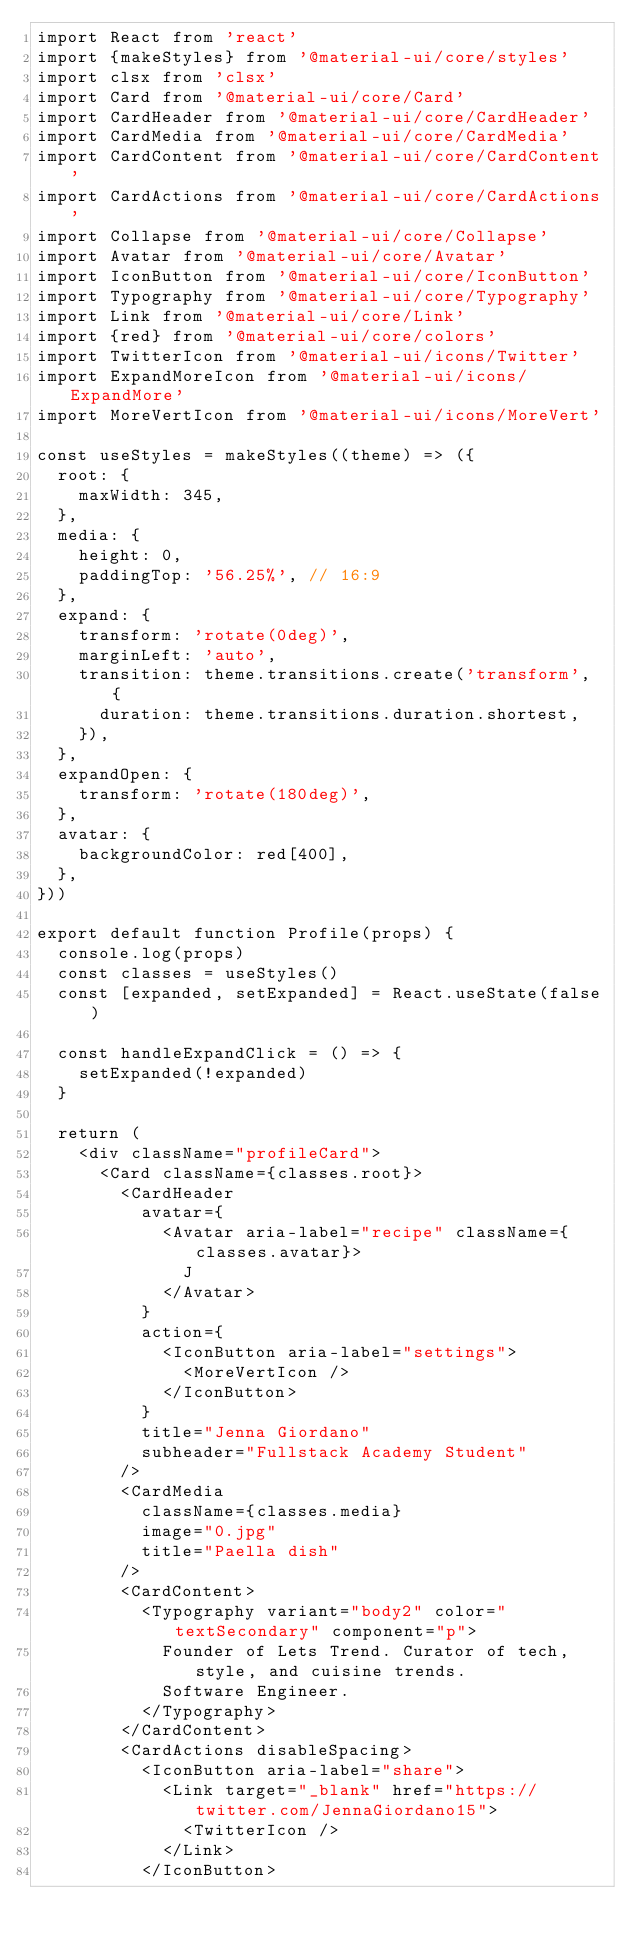<code> <loc_0><loc_0><loc_500><loc_500><_JavaScript_>import React from 'react'
import {makeStyles} from '@material-ui/core/styles'
import clsx from 'clsx'
import Card from '@material-ui/core/Card'
import CardHeader from '@material-ui/core/CardHeader'
import CardMedia from '@material-ui/core/CardMedia'
import CardContent from '@material-ui/core/CardContent'
import CardActions from '@material-ui/core/CardActions'
import Collapse from '@material-ui/core/Collapse'
import Avatar from '@material-ui/core/Avatar'
import IconButton from '@material-ui/core/IconButton'
import Typography from '@material-ui/core/Typography'
import Link from '@material-ui/core/Link'
import {red} from '@material-ui/core/colors'
import TwitterIcon from '@material-ui/icons/Twitter'
import ExpandMoreIcon from '@material-ui/icons/ExpandMore'
import MoreVertIcon from '@material-ui/icons/MoreVert'

const useStyles = makeStyles((theme) => ({
  root: {
    maxWidth: 345,
  },
  media: {
    height: 0,
    paddingTop: '56.25%', // 16:9
  },
  expand: {
    transform: 'rotate(0deg)',
    marginLeft: 'auto',
    transition: theme.transitions.create('transform', {
      duration: theme.transitions.duration.shortest,
    }),
  },
  expandOpen: {
    transform: 'rotate(180deg)',
  },
  avatar: {
    backgroundColor: red[400],
  },
}))

export default function Profile(props) {
  console.log(props)
  const classes = useStyles()
  const [expanded, setExpanded] = React.useState(false)

  const handleExpandClick = () => {
    setExpanded(!expanded)
  }

  return (
    <div className="profileCard">
      <Card className={classes.root}>
        <CardHeader
          avatar={
            <Avatar aria-label="recipe" className={classes.avatar}>
              J
            </Avatar>
          }
          action={
            <IconButton aria-label="settings">
              <MoreVertIcon />
            </IconButton>
          }
          title="Jenna Giordano"
          subheader="Fullstack Academy Student"
        />
        <CardMedia
          className={classes.media}
          image="0.jpg"
          title="Paella dish"
        />
        <CardContent>
          <Typography variant="body2" color="textSecondary" component="p">
            Founder of Lets Trend. Curator of tech, style, and cuisine trends.
            Software Engineer.
          </Typography>
        </CardContent>
        <CardActions disableSpacing>
          <IconButton aria-label="share">
            <Link target="_blank" href="https://twitter.com/JennaGiordano15">
              <TwitterIcon />
            </Link>
          </IconButton></code> 